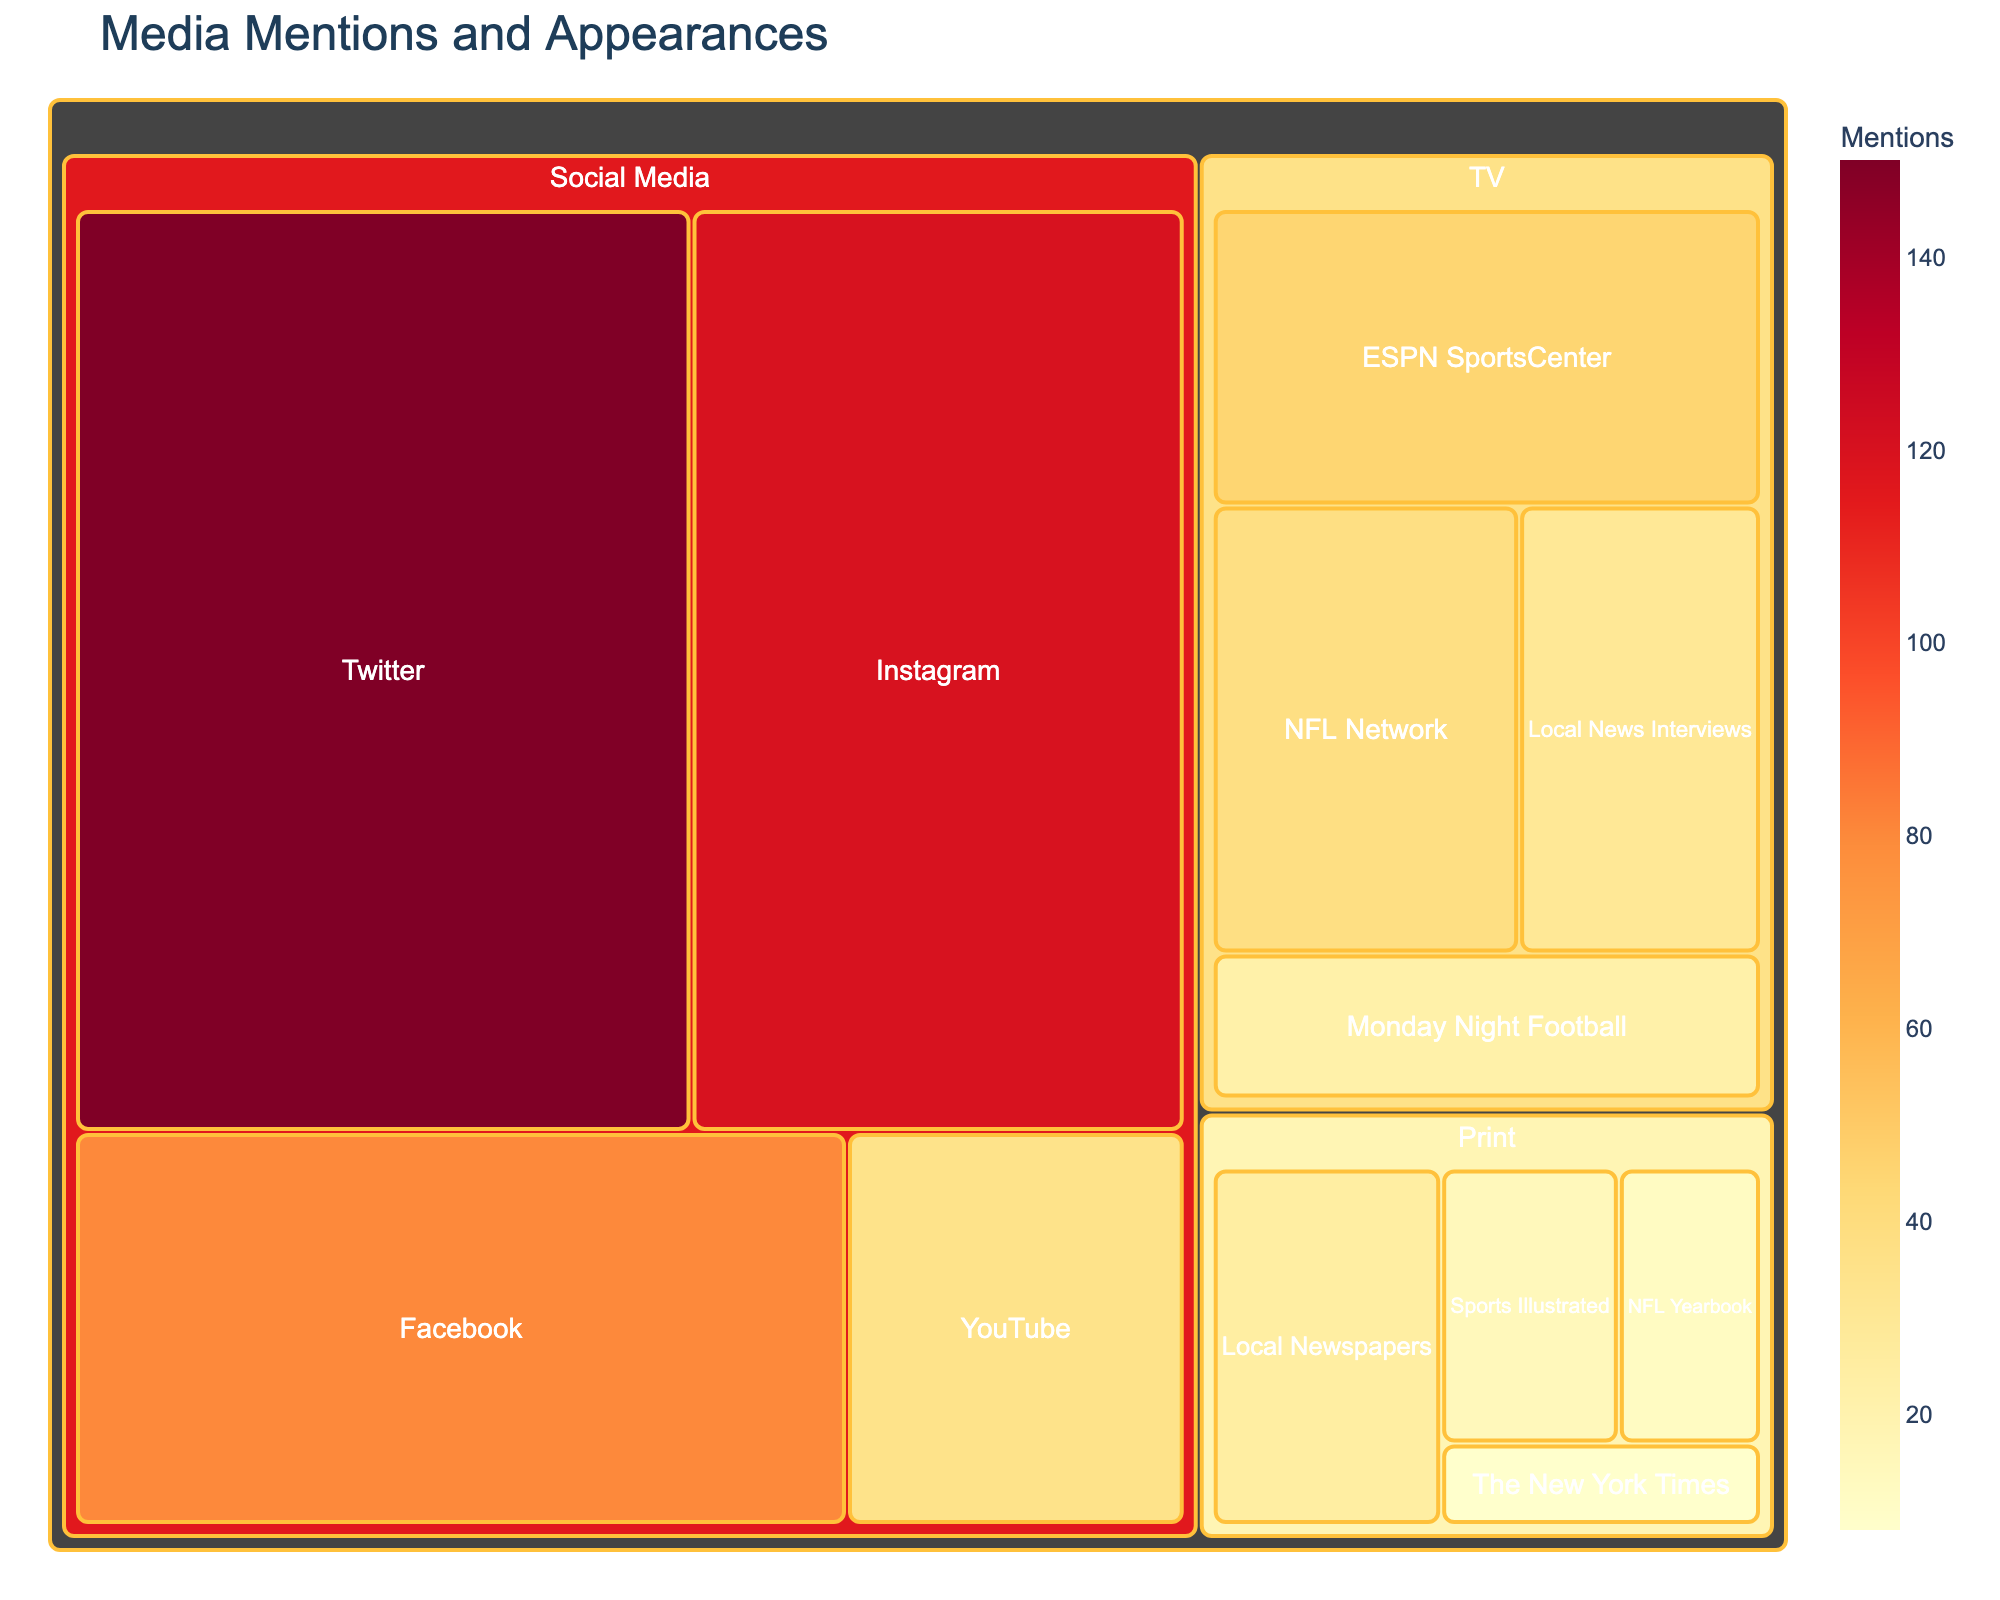What's the primary category with the most mentions? The treemap visually represents the number of media mentions categorized by type, with different colors indicating the value. The largest block segment under 'Social Media' indicates it has the highest mentions. Social Media has 385 total mentions.
Answer: Social Media Which subcategory has the highest occurrences within the entire dataset? Observing the blocks, the subcategory with the largest area under any category reflects the highest number of mentions. Here, 'Twitter' in Social Media has the largest area indicating 150 mentions.
Answer: Twitter How many more mentions does Twitter have compared to ESPN SportsCenter? Locate the mentions for 'Twitter' and 'ESPN SportsCenter'. Twitter has 150 mentions while ESPN SportsCenter has 45. Subtract 45 from 150 to find the difference: 150 - 45 = 105 mentions.
Answer: 105 Which media category has the least total mentions? Sum the values of each subcategory under each main category to find the total mentions. TV has 135, Print has 60, and Social Media has 385. The category with the least total is Print with only 60 mentions.
Answer: Print What is the combined total of mentions from Local News Interviews and Local Newspapers? Both 'Local News Interviews' under TV and 'Local Newspapers' under Print have their respective mentions. Add 30 (TV) and 25 (Print) to get the combined total: 30 + 25 = 55 mentions.
Answer: 55 How does the total number of mentions in Print compare to Social Media? Calculate the sum of mentions under each category: Print (15 + 8 + 25 + 12 = 60), Social Media (150 + 120 + 80 + 35 = 385). Compare the totals: Social Media with 385 mentions is significantly higher than Print with just 60 mentions.
Answer: Social Media has more mentions Within Social Media, which platform has the fewest mentions? Assess the values listed under Social Media subcategories and identify the lowest one. YouTube has the fewest with only 35 mentions.
Answer: YouTube How many total mentions are there across all subcategories? Sum all the values provided in the dataset across every subcategory: (45 + 38 + 22 + 30) + (15 + 8 + 25 + 12) + (150 + 120 + 80 + 35) = 135 + 60 + 385 = 580 mentions.
Answer: 580 